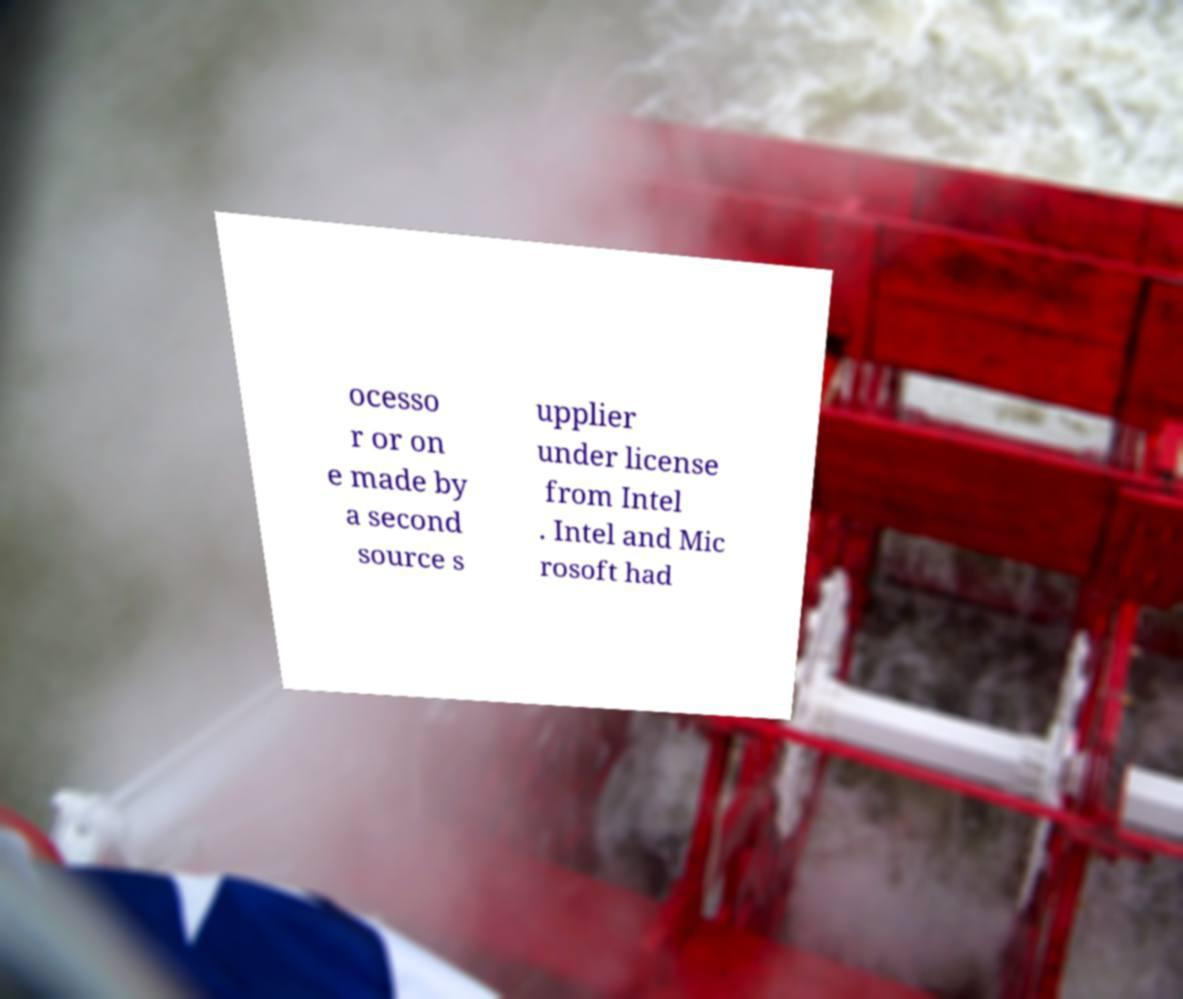Can you accurately transcribe the text from the provided image for me? ocesso r or on e made by a second source s upplier under license from Intel . Intel and Mic rosoft had 